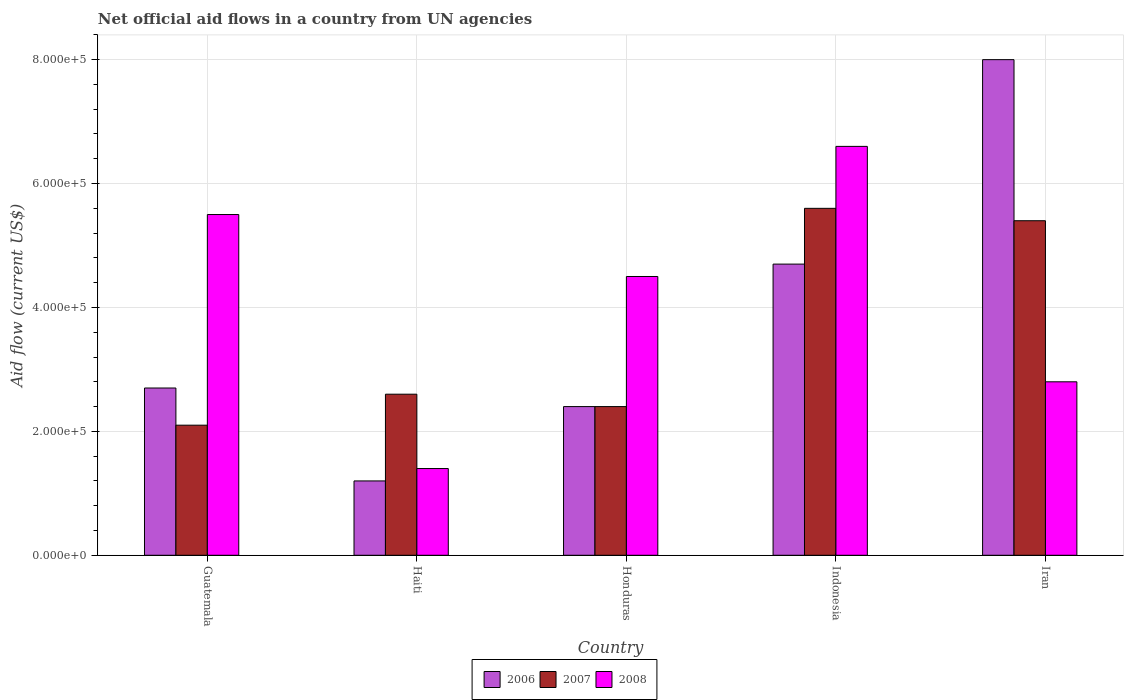Are the number of bars per tick equal to the number of legend labels?
Your answer should be very brief. Yes. How many bars are there on the 4th tick from the left?
Your answer should be compact. 3. How many bars are there on the 5th tick from the right?
Provide a succinct answer. 3. What is the label of the 3rd group of bars from the left?
Provide a short and direct response. Honduras. In how many cases, is the number of bars for a given country not equal to the number of legend labels?
Give a very brief answer. 0. Across all countries, what is the maximum net official aid flow in 2008?
Offer a very short reply. 6.60e+05. Across all countries, what is the minimum net official aid flow in 2006?
Ensure brevity in your answer.  1.20e+05. In which country was the net official aid flow in 2007 maximum?
Give a very brief answer. Indonesia. In which country was the net official aid flow in 2008 minimum?
Your answer should be very brief. Haiti. What is the total net official aid flow in 2007 in the graph?
Provide a short and direct response. 1.81e+06. What is the difference between the net official aid flow in 2007 in Guatemala and that in Indonesia?
Provide a succinct answer. -3.50e+05. What is the difference between the net official aid flow in 2008 in Indonesia and the net official aid flow in 2007 in Iran?
Make the answer very short. 1.20e+05. In how many countries, is the net official aid flow in 2007 greater than 80000 US$?
Give a very brief answer. 5. What is the ratio of the net official aid flow in 2007 in Haiti to that in Indonesia?
Ensure brevity in your answer.  0.46. Is the net official aid flow in 2007 in Honduras less than that in Indonesia?
Make the answer very short. Yes. Is the difference between the net official aid flow in 2006 in Haiti and Honduras greater than the difference between the net official aid flow in 2008 in Haiti and Honduras?
Your answer should be compact. Yes. In how many countries, is the net official aid flow in 2008 greater than the average net official aid flow in 2008 taken over all countries?
Provide a succinct answer. 3. Is the sum of the net official aid flow in 2008 in Guatemala and Indonesia greater than the maximum net official aid flow in 2007 across all countries?
Your answer should be very brief. Yes. What does the 2nd bar from the left in Guatemala represents?
Offer a very short reply. 2007. What does the 1st bar from the right in Honduras represents?
Make the answer very short. 2008. How many countries are there in the graph?
Make the answer very short. 5. What is the difference between two consecutive major ticks on the Y-axis?
Your response must be concise. 2.00e+05. Are the values on the major ticks of Y-axis written in scientific E-notation?
Give a very brief answer. Yes. Does the graph contain any zero values?
Your answer should be very brief. No. Does the graph contain grids?
Ensure brevity in your answer.  Yes. Where does the legend appear in the graph?
Provide a succinct answer. Bottom center. How are the legend labels stacked?
Give a very brief answer. Horizontal. What is the title of the graph?
Offer a terse response. Net official aid flows in a country from UN agencies. Does "1966" appear as one of the legend labels in the graph?
Your answer should be compact. No. What is the label or title of the X-axis?
Ensure brevity in your answer.  Country. What is the label or title of the Y-axis?
Your answer should be compact. Aid flow (current US$). What is the Aid flow (current US$) in 2006 in Guatemala?
Provide a succinct answer. 2.70e+05. What is the Aid flow (current US$) of 2007 in Honduras?
Provide a succinct answer. 2.40e+05. What is the Aid flow (current US$) in 2007 in Indonesia?
Your answer should be very brief. 5.60e+05. What is the Aid flow (current US$) of 2008 in Indonesia?
Give a very brief answer. 6.60e+05. What is the Aid flow (current US$) of 2006 in Iran?
Offer a terse response. 8.00e+05. What is the Aid flow (current US$) of 2007 in Iran?
Make the answer very short. 5.40e+05. What is the Aid flow (current US$) of 2008 in Iran?
Your answer should be compact. 2.80e+05. Across all countries, what is the maximum Aid flow (current US$) in 2007?
Your answer should be compact. 5.60e+05. Across all countries, what is the minimum Aid flow (current US$) of 2007?
Offer a terse response. 2.10e+05. Across all countries, what is the minimum Aid flow (current US$) in 2008?
Your answer should be very brief. 1.40e+05. What is the total Aid flow (current US$) of 2006 in the graph?
Ensure brevity in your answer.  1.90e+06. What is the total Aid flow (current US$) in 2007 in the graph?
Give a very brief answer. 1.81e+06. What is the total Aid flow (current US$) in 2008 in the graph?
Provide a succinct answer. 2.08e+06. What is the difference between the Aid flow (current US$) in 2006 in Guatemala and that in Haiti?
Your answer should be very brief. 1.50e+05. What is the difference between the Aid flow (current US$) in 2006 in Guatemala and that in Honduras?
Offer a terse response. 3.00e+04. What is the difference between the Aid flow (current US$) in 2008 in Guatemala and that in Honduras?
Keep it short and to the point. 1.00e+05. What is the difference between the Aid flow (current US$) in 2007 in Guatemala and that in Indonesia?
Provide a short and direct response. -3.50e+05. What is the difference between the Aid flow (current US$) in 2008 in Guatemala and that in Indonesia?
Give a very brief answer. -1.10e+05. What is the difference between the Aid flow (current US$) in 2006 in Guatemala and that in Iran?
Your response must be concise. -5.30e+05. What is the difference between the Aid flow (current US$) in 2007 in Guatemala and that in Iran?
Make the answer very short. -3.30e+05. What is the difference between the Aid flow (current US$) in 2006 in Haiti and that in Honduras?
Offer a terse response. -1.20e+05. What is the difference between the Aid flow (current US$) of 2008 in Haiti and that in Honduras?
Offer a very short reply. -3.10e+05. What is the difference between the Aid flow (current US$) of 2006 in Haiti and that in Indonesia?
Your answer should be very brief. -3.50e+05. What is the difference between the Aid flow (current US$) in 2008 in Haiti and that in Indonesia?
Make the answer very short. -5.20e+05. What is the difference between the Aid flow (current US$) in 2006 in Haiti and that in Iran?
Give a very brief answer. -6.80e+05. What is the difference between the Aid flow (current US$) in 2007 in Haiti and that in Iran?
Give a very brief answer. -2.80e+05. What is the difference between the Aid flow (current US$) of 2007 in Honduras and that in Indonesia?
Ensure brevity in your answer.  -3.20e+05. What is the difference between the Aid flow (current US$) in 2008 in Honduras and that in Indonesia?
Your answer should be compact. -2.10e+05. What is the difference between the Aid flow (current US$) of 2006 in Honduras and that in Iran?
Give a very brief answer. -5.60e+05. What is the difference between the Aid flow (current US$) of 2007 in Honduras and that in Iran?
Provide a short and direct response. -3.00e+05. What is the difference between the Aid flow (current US$) of 2006 in Indonesia and that in Iran?
Provide a succinct answer. -3.30e+05. What is the difference between the Aid flow (current US$) in 2007 in Indonesia and that in Iran?
Ensure brevity in your answer.  2.00e+04. What is the difference between the Aid flow (current US$) in 2006 in Guatemala and the Aid flow (current US$) in 2007 in Haiti?
Provide a short and direct response. 10000. What is the difference between the Aid flow (current US$) of 2006 in Guatemala and the Aid flow (current US$) of 2008 in Haiti?
Your answer should be very brief. 1.30e+05. What is the difference between the Aid flow (current US$) in 2006 in Guatemala and the Aid flow (current US$) in 2007 in Honduras?
Your answer should be very brief. 3.00e+04. What is the difference between the Aid flow (current US$) in 2006 in Guatemala and the Aid flow (current US$) in 2008 in Honduras?
Your response must be concise. -1.80e+05. What is the difference between the Aid flow (current US$) in 2006 in Guatemala and the Aid flow (current US$) in 2008 in Indonesia?
Make the answer very short. -3.90e+05. What is the difference between the Aid flow (current US$) in 2007 in Guatemala and the Aid flow (current US$) in 2008 in Indonesia?
Make the answer very short. -4.50e+05. What is the difference between the Aid flow (current US$) in 2006 in Guatemala and the Aid flow (current US$) in 2007 in Iran?
Ensure brevity in your answer.  -2.70e+05. What is the difference between the Aid flow (current US$) in 2006 in Guatemala and the Aid flow (current US$) in 2008 in Iran?
Provide a short and direct response. -10000. What is the difference between the Aid flow (current US$) in 2007 in Guatemala and the Aid flow (current US$) in 2008 in Iran?
Your response must be concise. -7.00e+04. What is the difference between the Aid flow (current US$) in 2006 in Haiti and the Aid flow (current US$) in 2007 in Honduras?
Provide a short and direct response. -1.20e+05. What is the difference between the Aid flow (current US$) in 2006 in Haiti and the Aid flow (current US$) in 2008 in Honduras?
Make the answer very short. -3.30e+05. What is the difference between the Aid flow (current US$) in 2007 in Haiti and the Aid flow (current US$) in 2008 in Honduras?
Provide a succinct answer. -1.90e+05. What is the difference between the Aid flow (current US$) of 2006 in Haiti and the Aid flow (current US$) of 2007 in Indonesia?
Your response must be concise. -4.40e+05. What is the difference between the Aid flow (current US$) in 2006 in Haiti and the Aid flow (current US$) in 2008 in Indonesia?
Offer a very short reply. -5.40e+05. What is the difference between the Aid flow (current US$) of 2007 in Haiti and the Aid flow (current US$) of 2008 in Indonesia?
Give a very brief answer. -4.00e+05. What is the difference between the Aid flow (current US$) of 2006 in Haiti and the Aid flow (current US$) of 2007 in Iran?
Your answer should be very brief. -4.20e+05. What is the difference between the Aid flow (current US$) in 2006 in Honduras and the Aid flow (current US$) in 2007 in Indonesia?
Your answer should be very brief. -3.20e+05. What is the difference between the Aid flow (current US$) in 2006 in Honduras and the Aid flow (current US$) in 2008 in Indonesia?
Your response must be concise. -4.20e+05. What is the difference between the Aid flow (current US$) of 2007 in Honduras and the Aid flow (current US$) of 2008 in Indonesia?
Offer a very short reply. -4.20e+05. What is the difference between the Aid flow (current US$) in 2006 in Honduras and the Aid flow (current US$) in 2007 in Iran?
Your answer should be very brief. -3.00e+05. What is the difference between the Aid flow (current US$) in 2006 in Honduras and the Aid flow (current US$) in 2008 in Iran?
Provide a short and direct response. -4.00e+04. What is the difference between the Aid flow (current US$) in 2006 in Indonesia and the Aid flow (current US$) in 2007 in Iran?
Keep it short and to the point. -7.00e+04. What is the difference between the Aid flow (current US$) of 2007 in Indonesia and the Aid flow (current US$) of 2008 in Iran?
Your response must be concise. 2.80e+05. What is the average Aid flow (current US$) of 2006 per country?
Ensure brevity in your answer.  3.80e+05. What is the average Aid flow (current US$) of 2007 per country?
Your response must be concise. 3.62e+05. What is the average Aid flow (current US$) in 2008 per country?
Your answer should be compact. 4.16e+05. What is the difference between the Aid flow (current US$) of 2006 and Aid flow (current US$) of 2007 in Guatemala?
Offer a terse response. 6.00e+04. What is the difference between the Aid flow (current US$) of 2006 and Aid flow (current US$) of 2008 in Guatemala?
Offer a terse response. -2.80e+05. What is the difference between the Aid flow (current US$) of 2007 and Aid flow (current US$) of 2008 in Guatemala?
Provide a succinct answer. -3.40e+05. What is the difference between the Aid flow (current US$) of 2006 and Aid flow (current US$) of 2007 in Indonesia?
Make the answer very short. -9.00e+04. What is the difference between the Aid flow (current US$) of 2006 and Aid flow (current US$) of 2008 in Indonesia?
Make the answer very short. -1.90e+05. What is the difference between the Aid flow (current US$) in 2007 and Aid flow (current US$) in 2008 in Indonesia?
Ensure brevity in your answer.  -1.00e+05. What is the difference between the Aid flow (current US$) in 2006 and Aid flow (current US$) in 2008 in Iran?
Make the answer very short. 5.20e+05. What is the difference between the Aid flow (current US$) in 2007 and Aid flow (current US$) in 2008 in Iran?
Your answer should be very brief. 2.60e+05. What is the ratio of the Aid flow (current US$) in 2006 in Guatemala to that in Haiti?
Your answer should be very brief. 2.25. What is the ratio of the Aid flow (current US$) in 2007 in Guatemala to that in Haiti?
Provide a succinct answer. 0.81. What is the ratio of the Aid flow (current US$) in 2008 in Guatemala to that in Haiti?
Your answer should be compact. 3.93. What is the ratio of the Aid flow (current US$) in 2006 in Guatemala to that in Honduras?
Keep it short and to the point. 1.12. What is the ratio of the Aid flow (current US$) in 2008 in Guatemala to that in Honduras?
Offer a very short reply. 1.22. What is the ratio of the Aid flow (current US$) of 2006 in Guatemala to that in Indonesia?
Offer a very short reply. 0.57. What is the ratio of the Aid flow (current US$) of 2006 in Guatemala to that in Iran?
Ensure brevity in your answer.  0.34. What is the ratio of the Aid flow (current US$) in 2007 in Guatemala to that in Iran?
Offer a very short reply. 0.39. What is the ratio of the Aid flow (current US$) in 2008 in Guatemala to that in Iran?
Ensure brevity in your answer.  1.96. What is the ratio of the Aid flow (current US$) in 2008 in Haiti to that in Honduras?
Offer a very short reply. 0.31. What is the ratio of the Aid flow (current US$) of 2006 in Haiti to that in Indonesia?
Make the answer very short. 0.26. What is the ratio of the Aid flow (current US$) of 2007 in Haiti to that in Indonesia?
Provide a short and direct response. 0.46. What is the ratio of the Aid flow (current US$) of 2008 in Haiti to that in Indonesia?
Provide a succinct answer. 0.21. What is the ratio of the Aid flow (current US$) of 2006 in Haiti to that in Iran?
Make the answer very short. 0.15. What is the ratio of the Aid flow (current US$) in 2007 in Haiti to that in Iran?
Your response must be concise. 0.48. What is the ratio of the Aid flow (current US$) in 2006 in Honduras to that in Indonesia?
Offer a very short reply. 0.51. What is the ratio of the Aid flow (current US$) of 2007 in Honduras to that in Indonesia?
Your answer should be compact. 0.43. What is the ratio of the Aid flow (current US$) of 2008 in Honduras to that in Indonesia?
Your response must be concise. 0.68. What is the ratio of the Aid flow (current US$) of 2006 in Honduras to that in Iran?
Offer a very short reply. 0.3. What is the ratio of the Aid flow (current US$) of 2007 in Honduras to that in Iran?
Your response must be concise. 0.44. What is the ratio of the Aid flow (current US$) in 2008 in Honduras to that in Iran?
Provide a short and direct response. 1.61. What is the ratio of the Aid flow (current US$) in 2006 in Indonesia to that in Iran?
Provide a short and direct response. 0.59. What is the ratio of the Aid flow (current US$) of 2008 in Indonesia to that in Iran?
Keep it short and to the point. 2.36. What is the difference between the highest and the lowest Aid flow (current US$) in 2006?
Ensure brevity in your answer.  6.80e+05. What is the difference between the highest and the lowest Aid flow (current US$) in 2007?
Your response must be concise. 3.50e+05. What is the difference between the highest and the lowest Aid flow (current US$) of 2008?
Your response must be concise. 5.20e+05. 